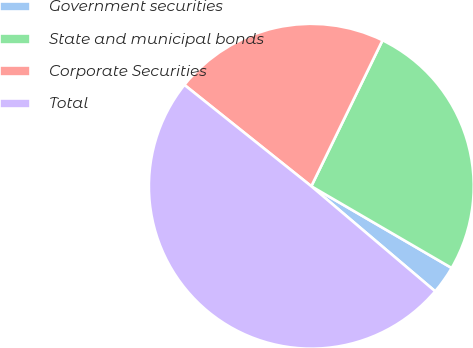Convert chart. <chart><loc_0><loc_0><loc_500><loc_500><pie_chart><fcel>Government securities<fcel>State and municipal bonds<fcel>Corporate Securities<fcel>Total<nl><fcel>2.8%<fcel>26.17%<fcel>21.5%<fcel>49.53%<nl></chart> 